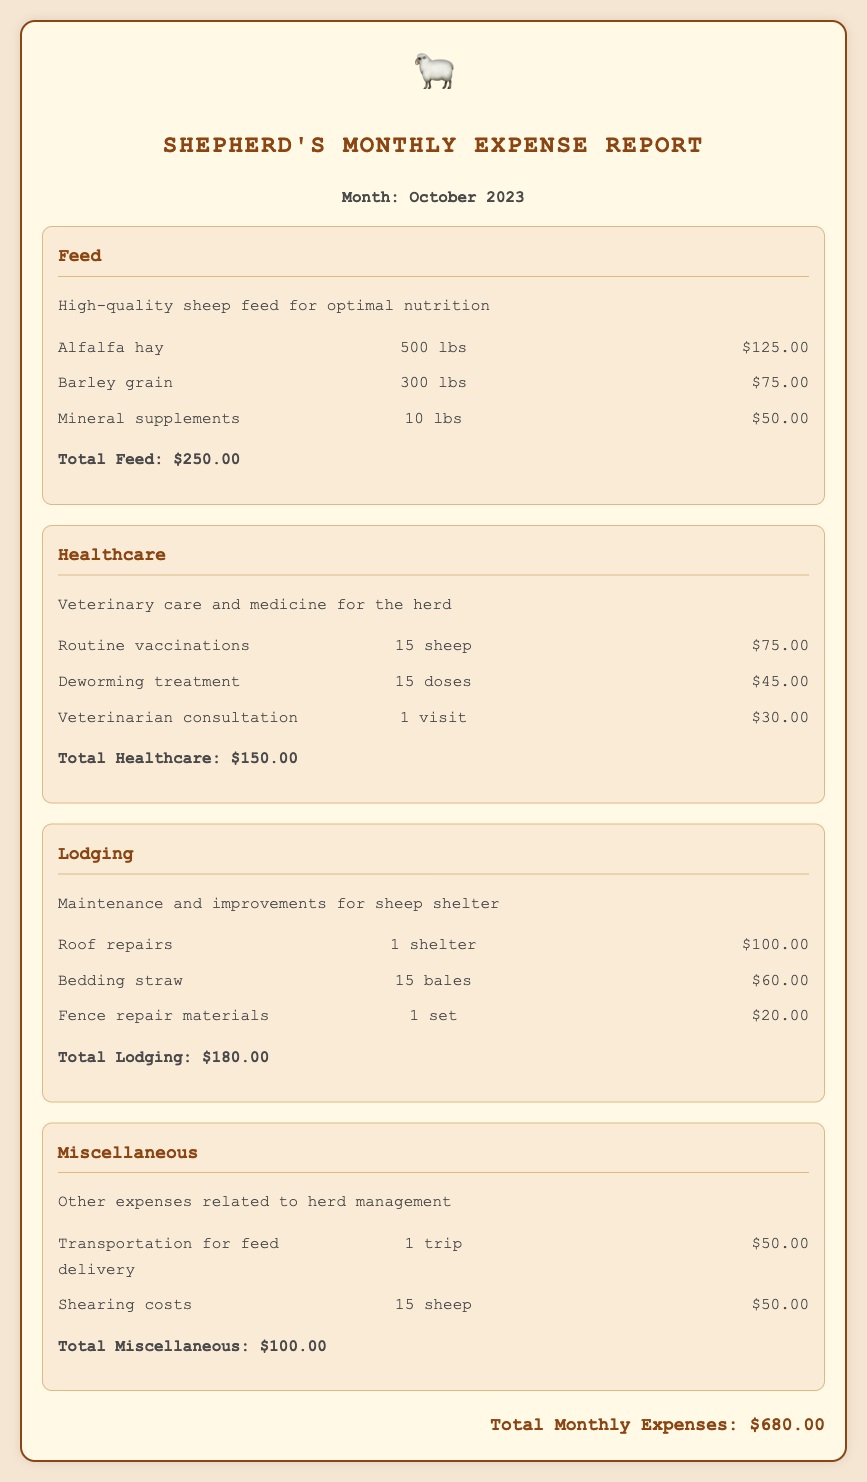What is the total cost of feed? The total cost of feed is stated as $250.00 in the document.
Answer: $250.00 How many sheep received routine vaccinations? The document specifies that 15 sheep received routine vaccinations.
Answer: 15 sheep What is included in healthcare expenses? The healthcare expenses consist of routine vaccinations, deworming treatment, and veterinarian consultation.
Answer: Routine vaccinations, deworming treatment, veterinarian consultation What is the cost of roof repairs? The document lists the cost of roof repairs as $100.00.
Answer: $100.00 What is the total for miscellaneous expenses? The total for miscellaneous expenses is $100.00, as stated in the document.
Answer: $100.00 How much was spent on bedding straw? The document indicates that bedding straw cost $60.00.
Answer: $60.00 What is the overall total of monthly expenses? The overall total of monthly expenses is indicated as $680.00 in the document.
Answer: $680.00 What is the month and year of this expense report? The report details the month as October and the year as 2023.
Answer: October 2023 How many pounds of barley grain were purchased? The document states that 300 lbs of barley grain were purchased.
Answer: 300 lbs 